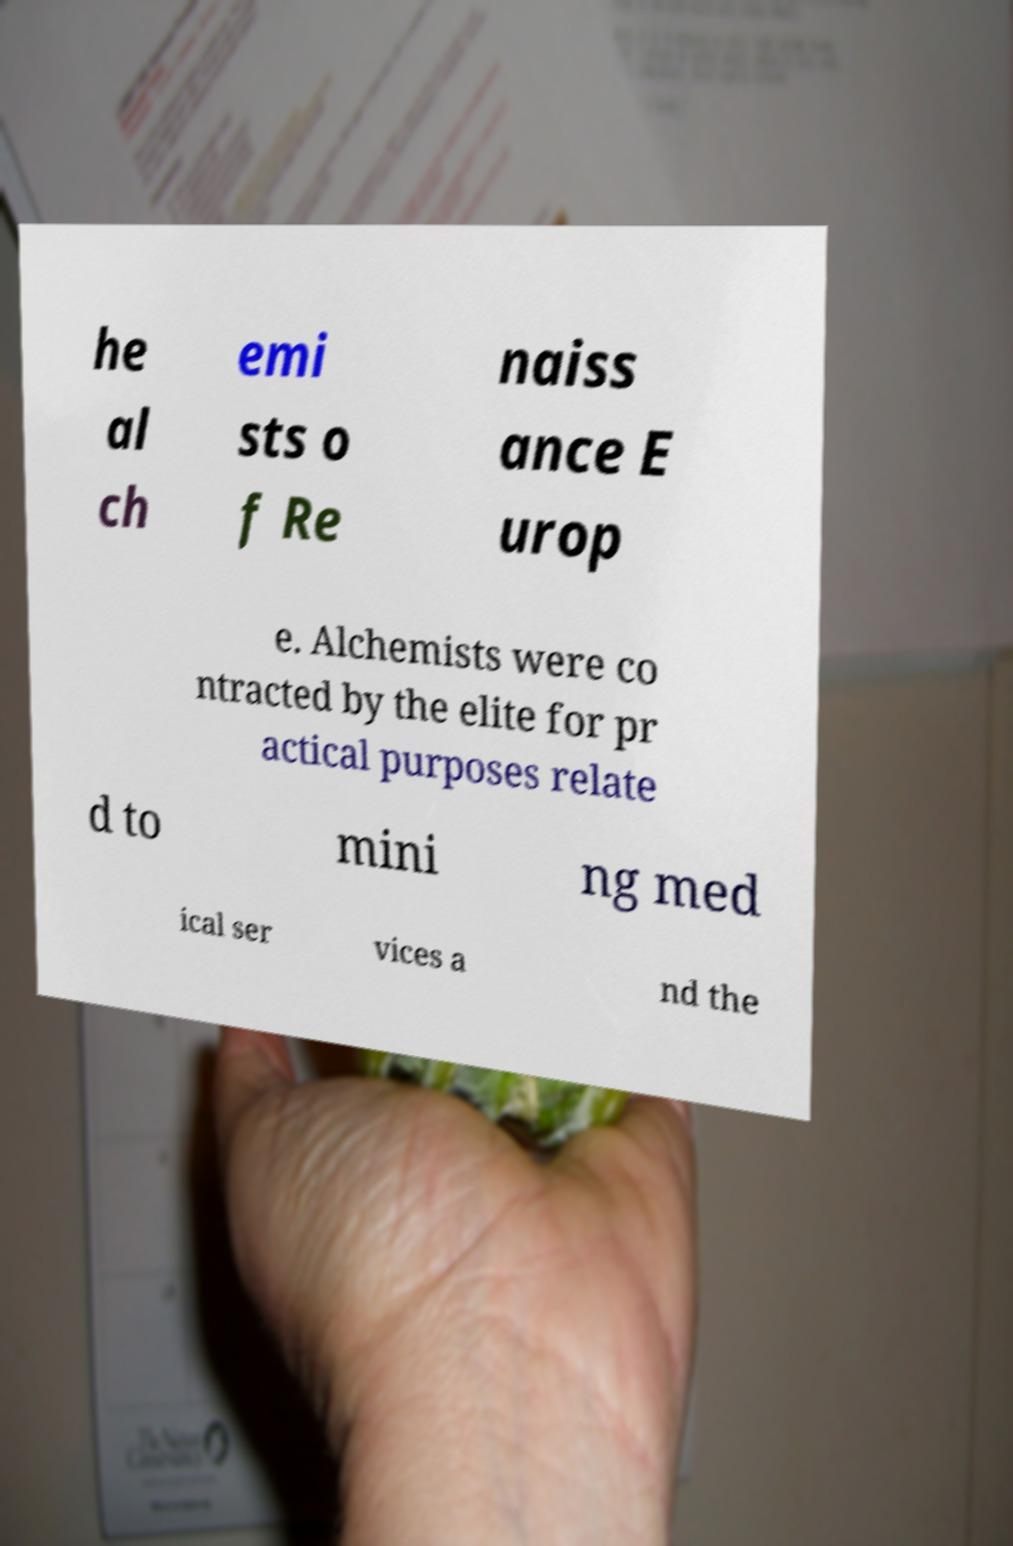Could you assist in decoding the text presented in this image and type it out clearly? he al ch emi sts o f Re naiss ance E urop e. Alchemists were co ntracted by the elite for pr actical purposes relate d to mini ng med ical ser vices a nd the 